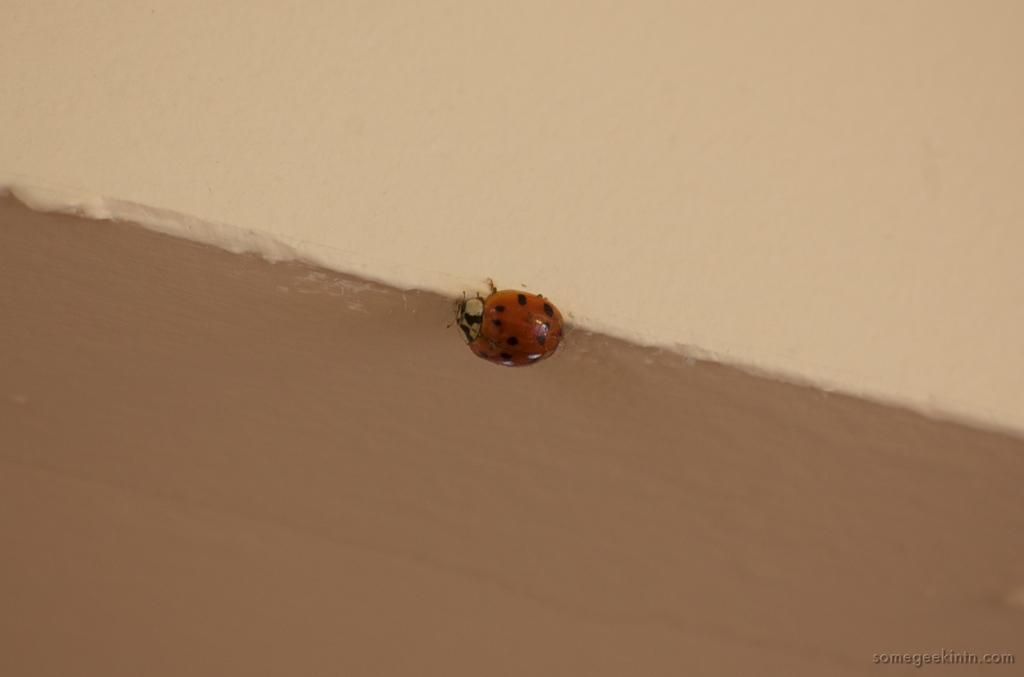What is on the wall in the image? There is a bug on the wall in the image. What can be seen below the bug on the wall? There is a brown painting below the bug. What can be seen above the bug on the wall? There is a cream painting above the bug. How does the bug contribute to the digestion process in the image? The image does not depict any digestion process, and the bug is not involved in any such activity. 